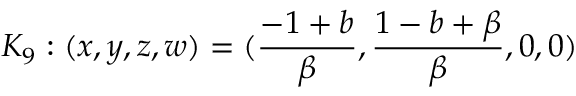Convert formula to latex. <formula><loc_0><loc_0><loc_500><loc_500>K _ { 9 } \colon ( x , y , z , w ) = ( \frac { - 1 + b } { \beta } , \frac { 1 - b + \beta } { \beta } , 0 , 0 )</formula> 